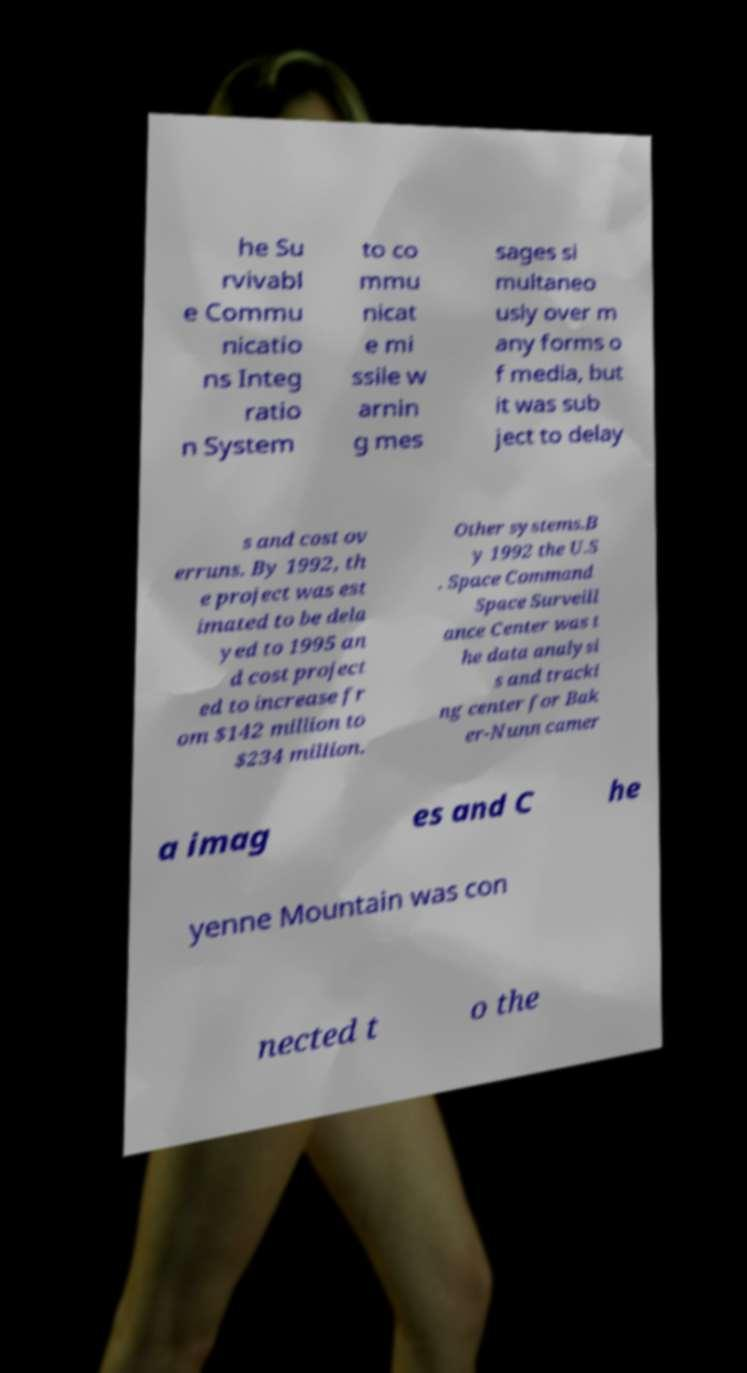There's text embedded in this image that I need extracted. Can you transcribe it verbatim? he Su rvivabl e Commu nicatio ns Integ ratio n System to co mmu nicat e mi ssile w arnin g mes sages si multaneo usly over m any forms o f media, but it was sub ject to delay s and cost ov erruns. By 1992, th e project was est imated to be dela yed to 1995 an d cost project ed to increase fr om $142 million to $234 million. Other systems.B y 1992 the U.S . Space Command Space Surveill ance Center was t he data analysi s and tracki ng center for Bak er-Nunn camer a imag es and C he yenne Mountain was con nected t o the 